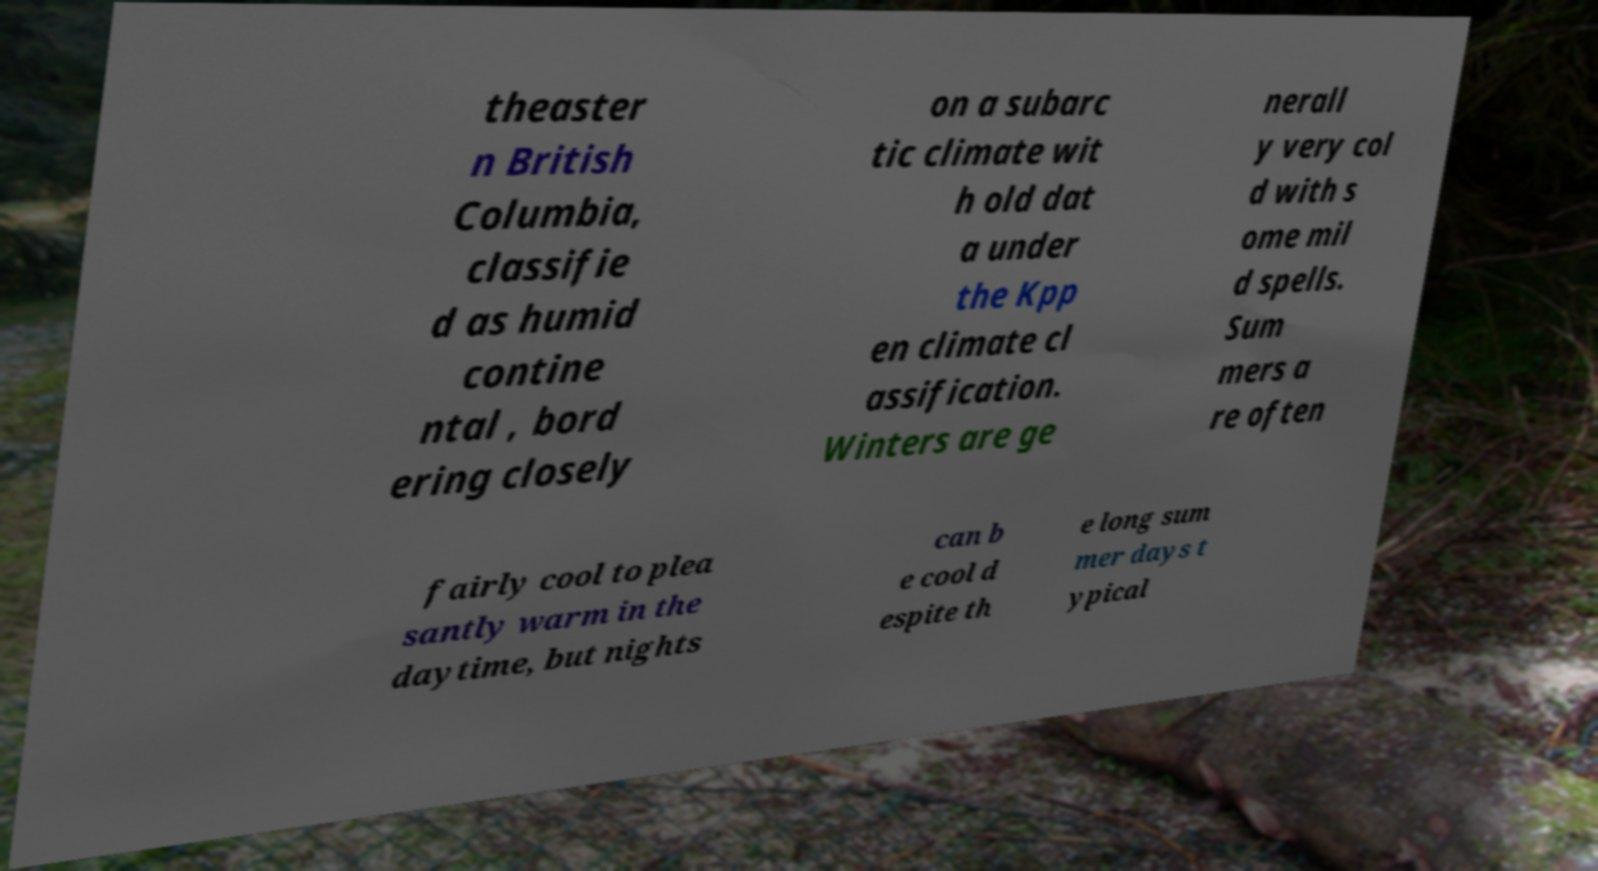Can you read and provide the text displayed in the image?This photo seems to have some interesting text. Can you extract and type it out for me? theaster n British Columbia, classifie d as humid contine ntal , bord ering closely on a subarc tic climate wit h old dat a under the Kpp en climate cl assification. Winters are ge nerall y very col d with s ome mil d spells. Sum mers a re often fairly cool to plea santly warm in the daytime, but nights can b e cool d espite th e long sum mer days t ypical 